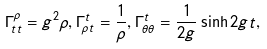Convert formula to latex. <formula><loc_0><loc_0><loc_500><loc_500>\Gamma _ { t t } ^ { \rho } = g ^ { 2 } \rho , \Gamma _ { \rho t } ^ { t } = \frac { 1 } { \rho } , \Gamma _ { \theta \theta } ^ { t } = \frac { 1 } { 2 g } \sinh 2 g t ,</formula> 